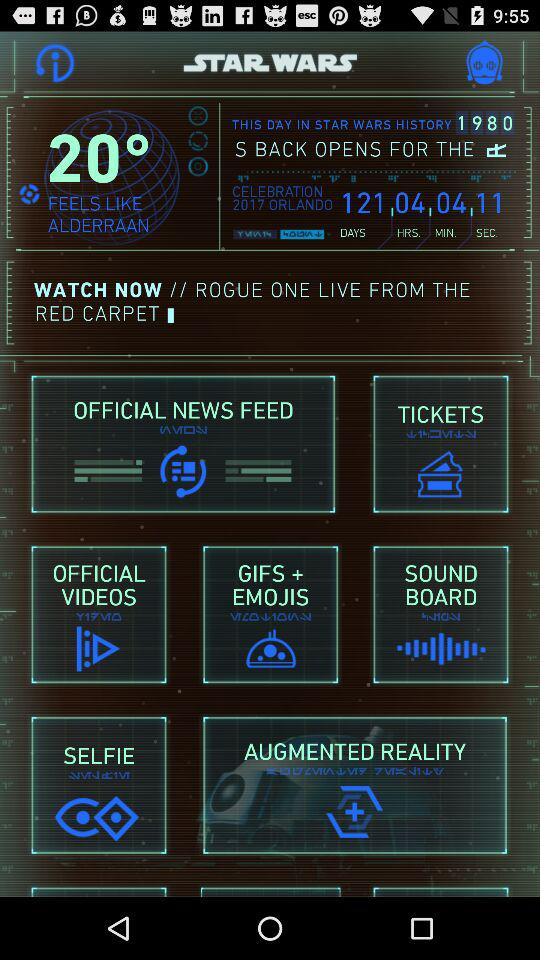How much time is left for the celebration? The remaining time is 121 days, 04 hours, 04 minutes, and 11 seconds. 